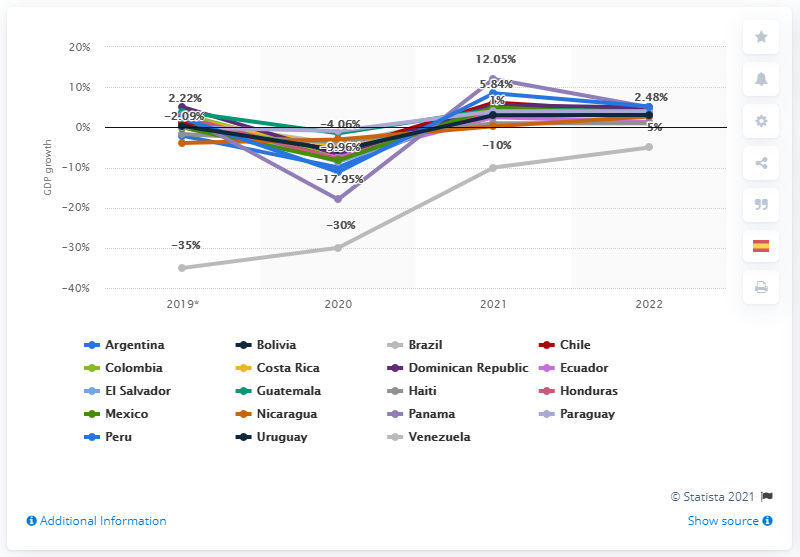Draw attention to some important aspects in this diagram. In 2021, Mexico's GDP was forecasted to increase by five percent. 